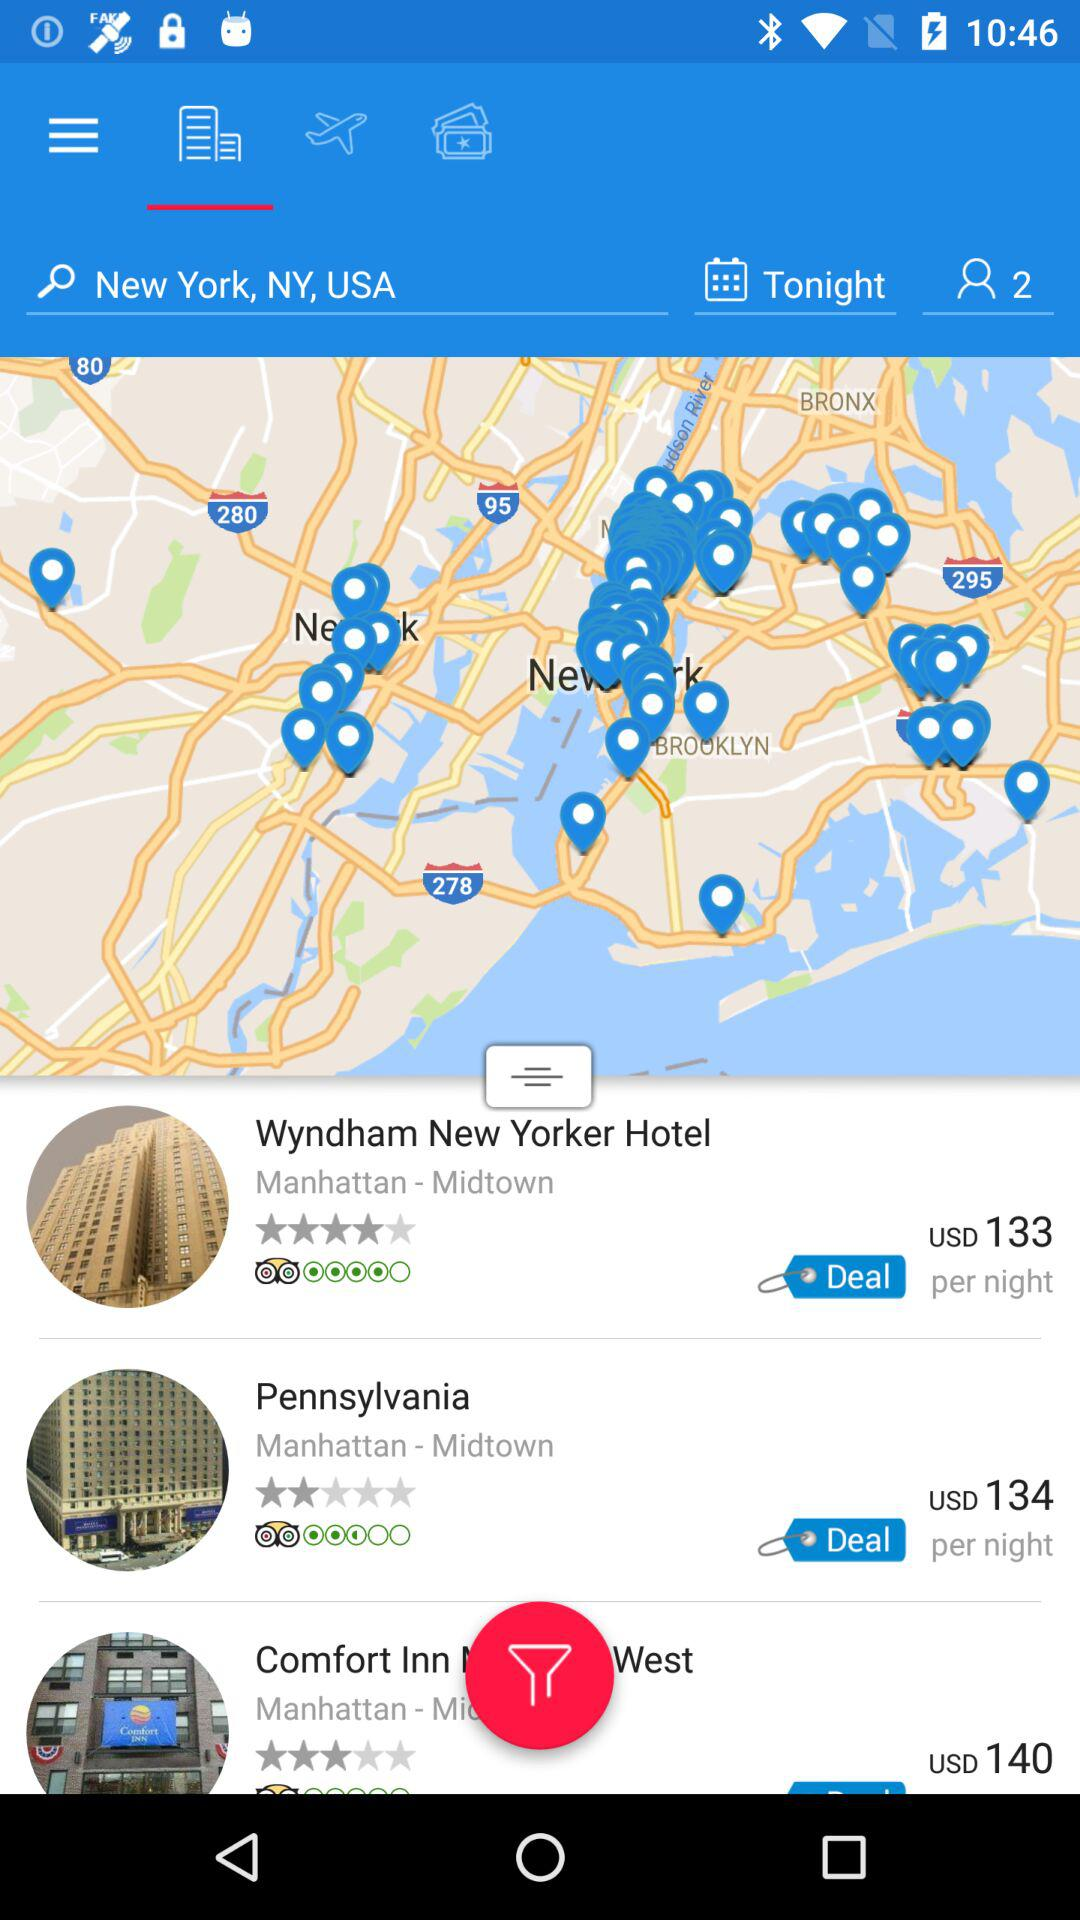What is the booking price of a room at the "Pennsylvania"? The booking price of a room at the "Pennsylvania" is 134 US dollars per night. 